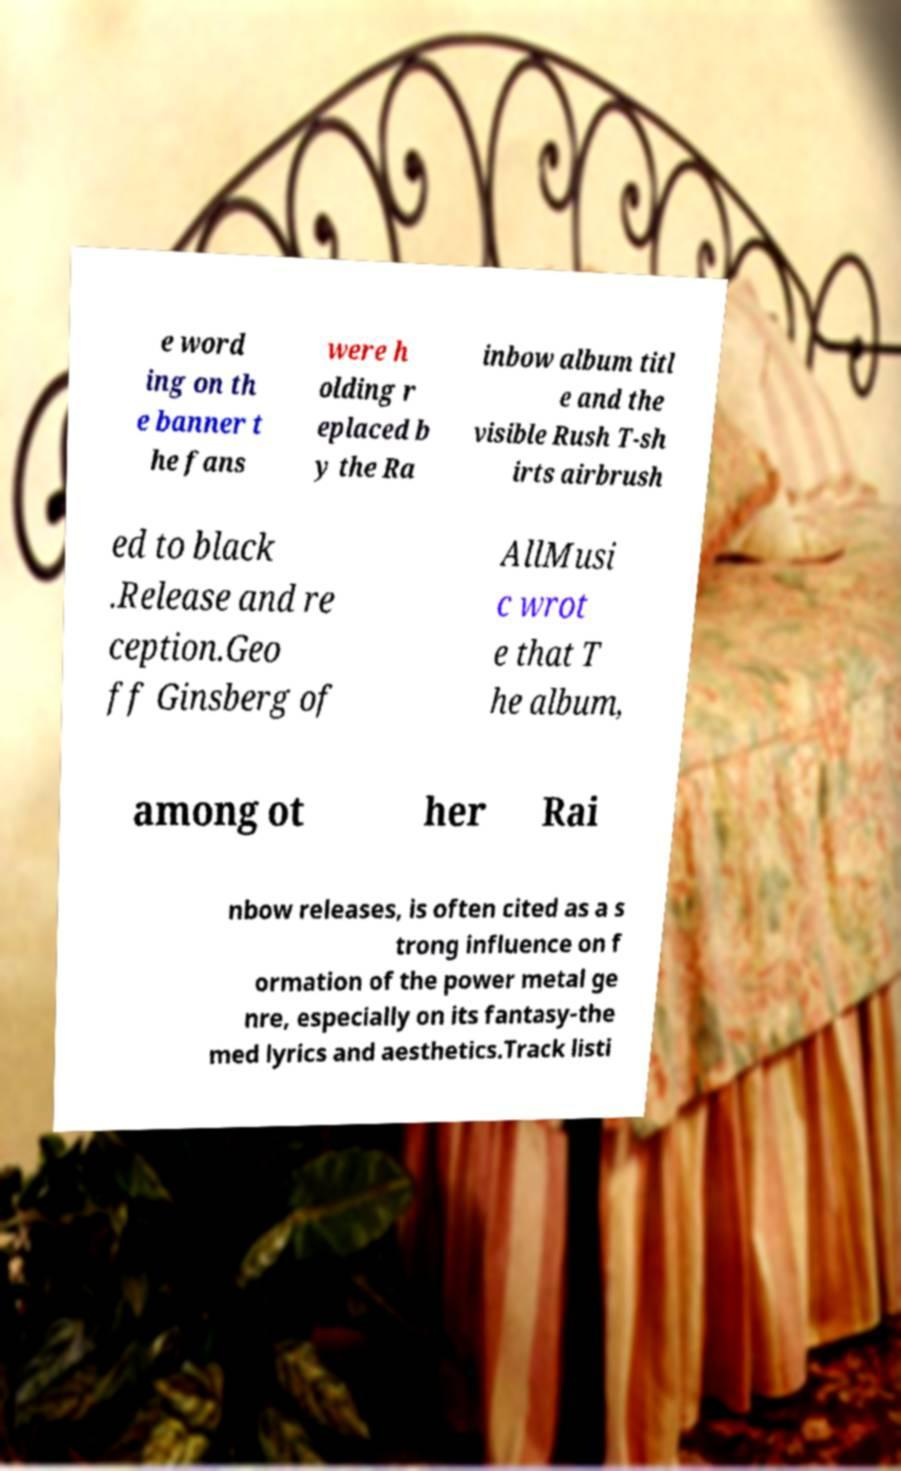Can you accurately transcribe the text from the provided image for me? e word ing on th e banner t he fans were h olding r eplaced b y the Ra inbow album titl e and the visible Rush T-sh irts airbrush ed to black .Release and re ception.Geo ff Ginsberg of AllMusi c wrot e that T he album, among ot her Rai nbow releases, is often cited as a s trong influence on f ormation of the power metal ge nre, especially on its fantasy-the med lyrics and aesthetics.Track listi 